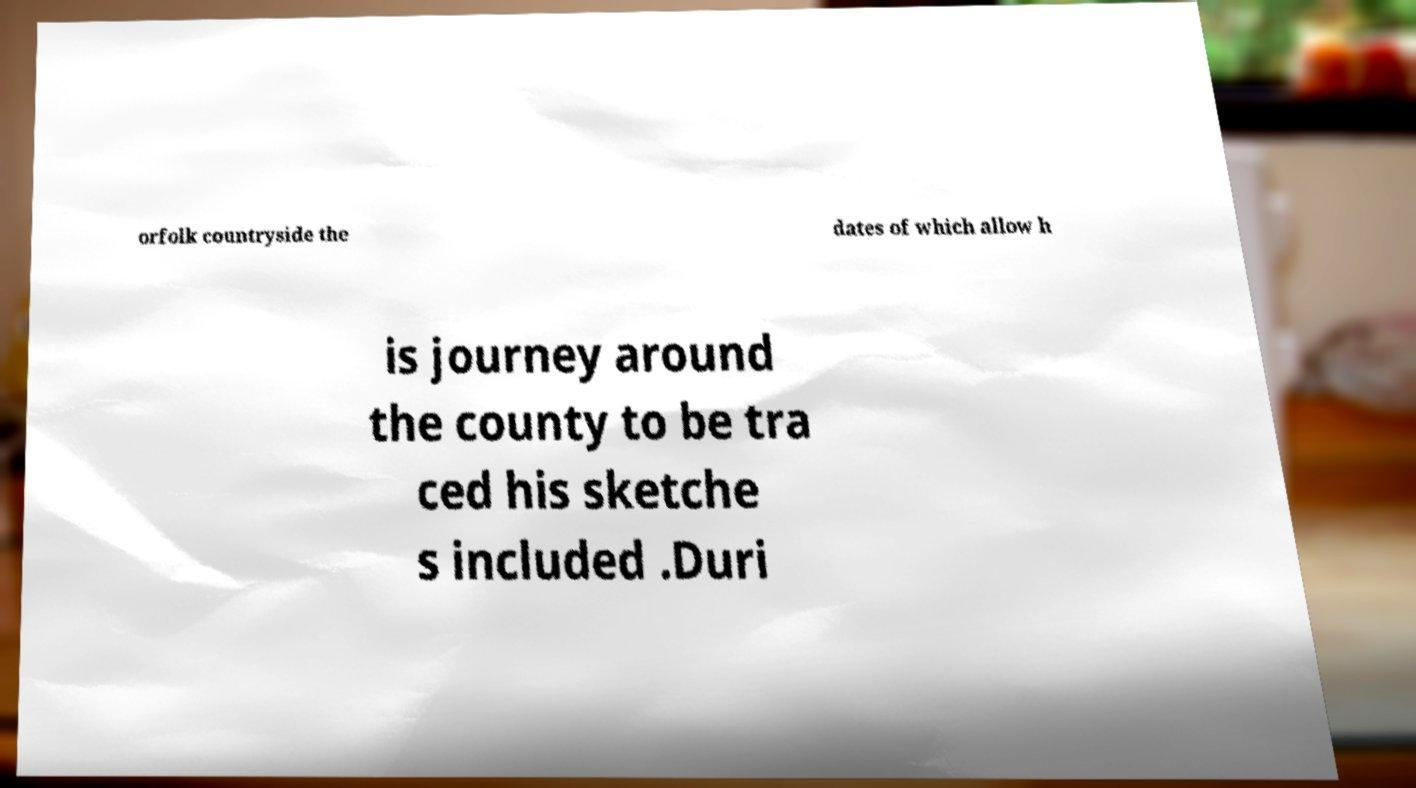Can you accurately transcribe the text from the provided image for me? orfolk countryside the dates of which allow h is journey around the county to be tra ced his sketche s included .Duri 